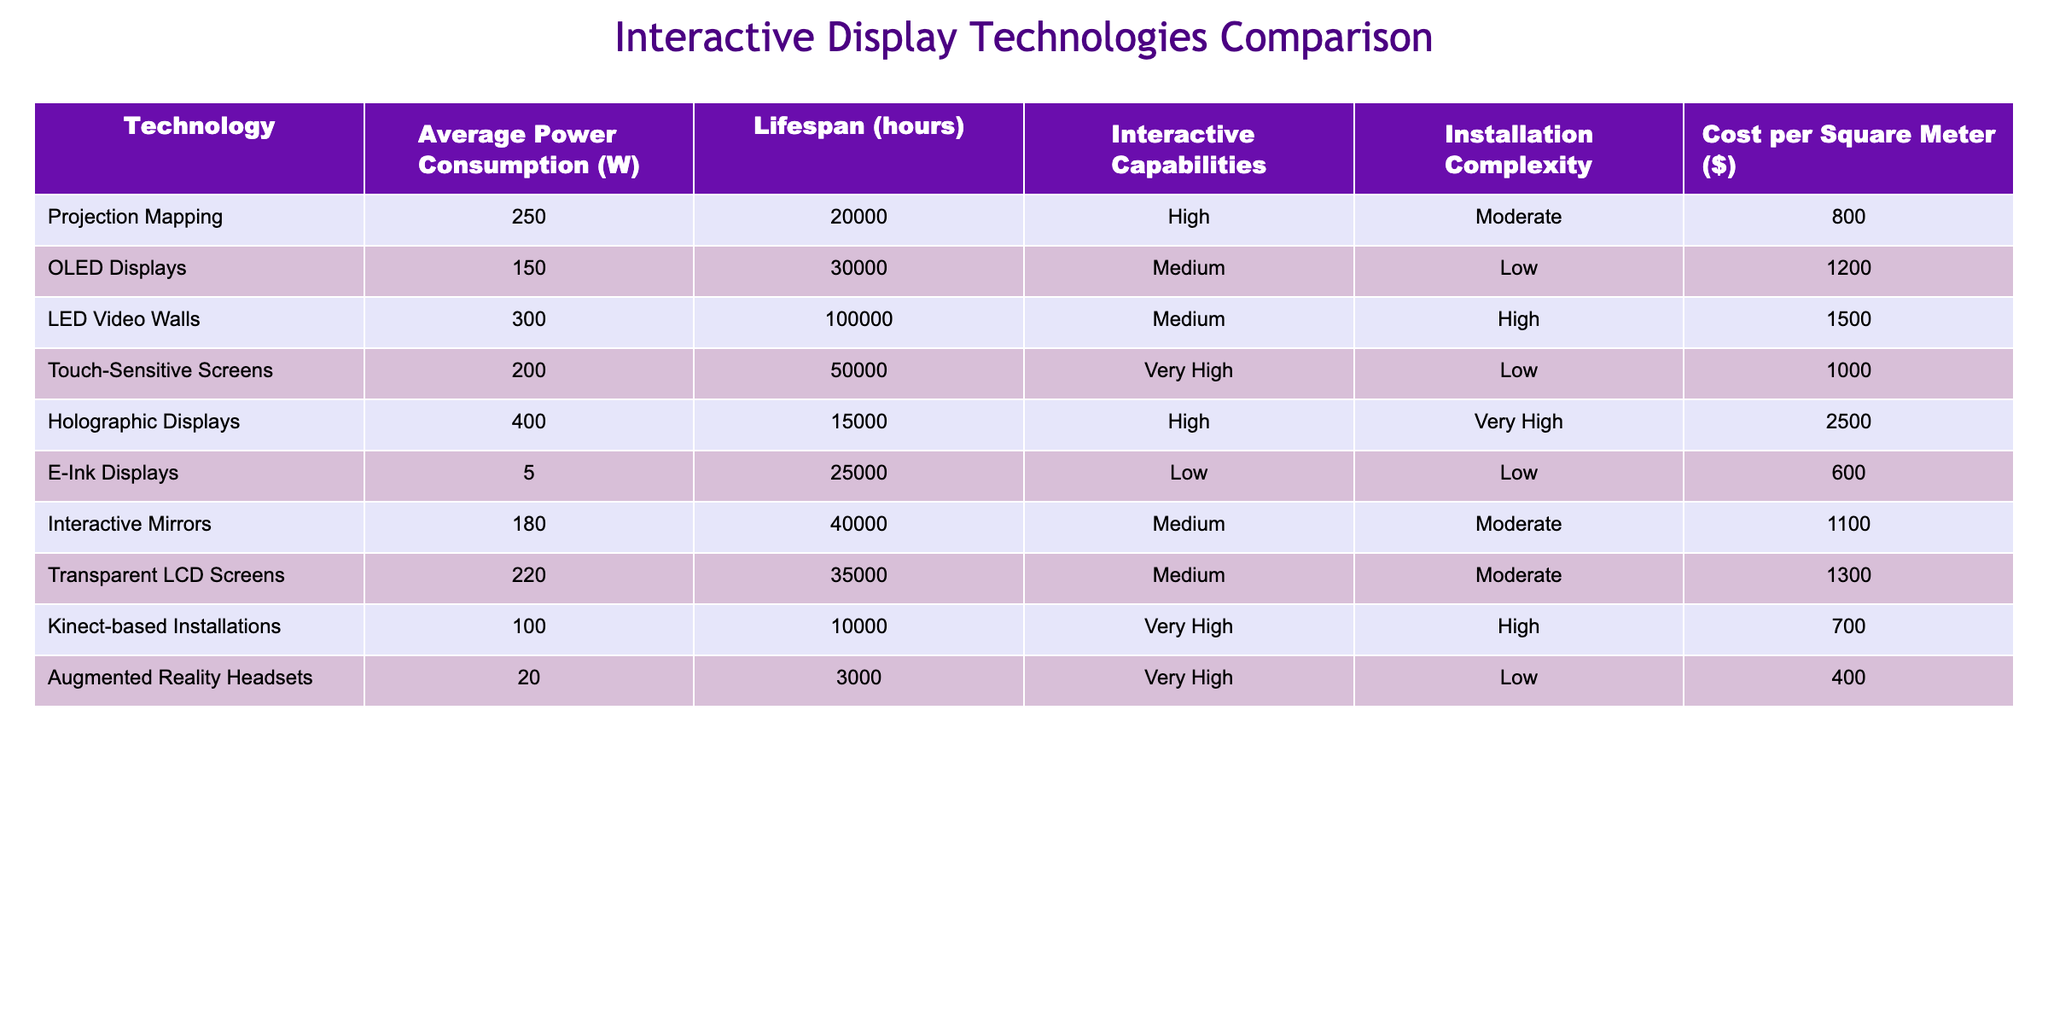What is the average power consumption of OLED Displays? The average power consumption of OLED Displays is directly listed in the table. It shows 150 W.
Answer: 150 W Which display technology has the highest average power consumption? By comparing the average power consumption values in the table, Holographic Displays have the highest value at 400 W.
Answer: Holographic Displays How many hours does a Touch-Sensitive Screen last on average? The average lifespan of a Touch-Sensitive Screen is indicated in the table as 50,000 hours.
Answer: 50000 hours What is the total power consumption of using both Projection Mapping and Kinect-based Installations? To find the total power consumption, we add the values from the table: Projection Mapping consumption (250 W) + Kinect-based Installations consumption (100 W) = 350 W.
Answer: 350 W Is the cost per square meter of Interactive Mirrors less than that of E-Ink Displays? The cost for Interactive Mirrors is listed as $1100, while E-Ink Displays cost $600. Since $1100 is greater than $600, the statement is false.
Answer: No Which technology has the longest lifespan and what is that lifespan? By checking the lifespan values in the table, LED Video Walls have the longest lifespan at 100,000 hours.
Answer: LED Video Walls, 100000 hours If the average cost of Augmented Reality Headsets is subtracted from the average cost of OLED Displays, what is the difference? The cost per square meter for OLED Displays is $1200 and for Augmented Reality Headsets, it is $400. The difference is $1200 - $400 = $800.
Answer: 800 Are all technologies listed in the table considered to have high interactive capabilities? Not all technologies have high interactive capabilities. For example, E-Ink Displays have low interactive capabilities, as per the table.
Answer: No What is the average lifespan of technologies categorized as having "Very High" interactive capabilities? The relevant technologies are Touch-Sensitive Screens (50,000 hours), Holographic Displays (15,000 hours), Kinect-based Installations (10,000 hours), and Augmented Reality Headsets (3,000 hours). The average is calculated as follows: (50000 + 15000 + 10000 + 3000) / 4 = 20000 hours.
Answer: 20000 hours 